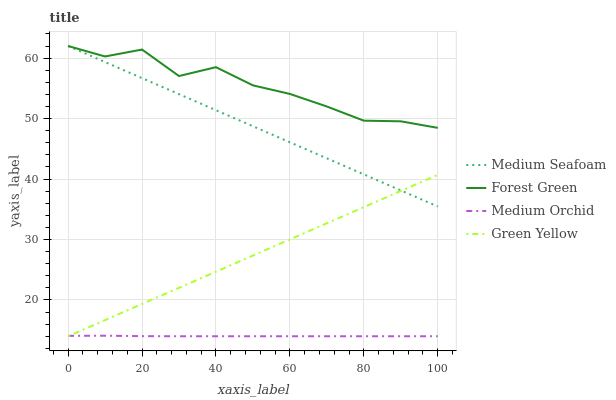Does Forest Green have the minimum area under the curve?
Answer yes or no. No. Does Medium Orchid have the maximum area under the curve?
Answer yes or no. No. Is Medium Orchid the smoothest?
Answer yes or no. No. Is Medium Orchid the roughest?
Answer yes or no. No. Does Forest Green have the lowest value?
Answer yes or no. No. Does Medium Orchid have the highest value?
Answer yes or no. No. Is Green Yellow less than Forest Green?
Answer yes or no. Yes. Is Forest Green greater than Green Yellow?
Answer yes or no. Yes. Does Green Yellow intersect Forest Green?
Answer yes or no. No. 